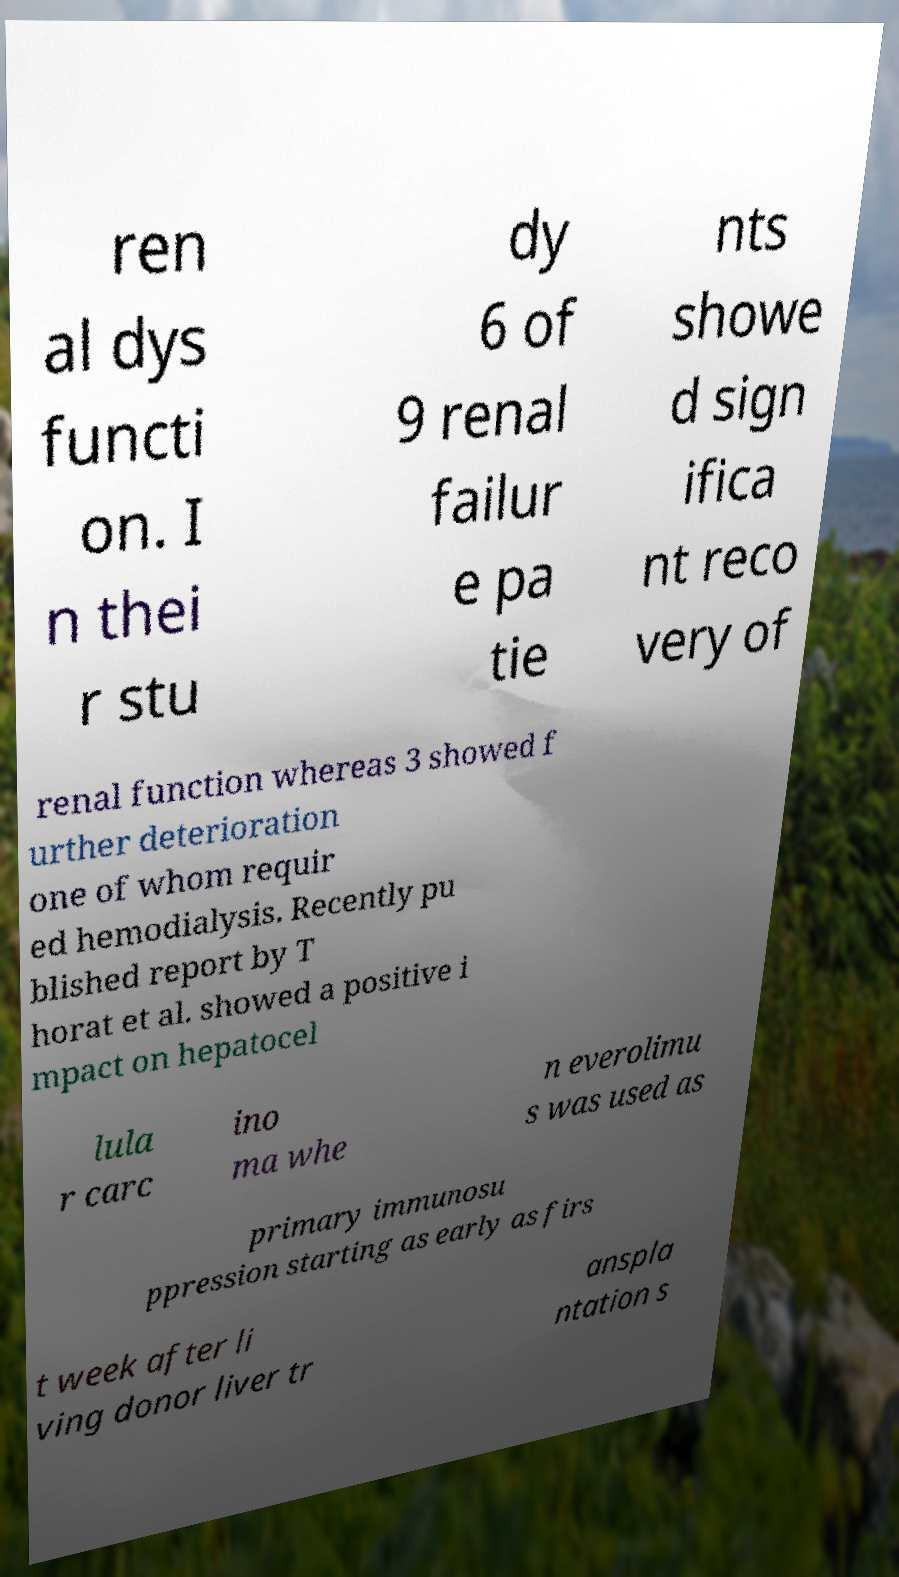Can you accurately transcribe the text from the provided image for me? ren al dys functi on. I n thei r stu dy 6 of 9 renal failur e pa tie nts showe d sign ifica nt reco very of renal function whereas 3 showed f urther deterioration one of whom requir ed hemodialysis. Recently pu blished report by T horat et al. showed a positive i mpact on hepatocel lula r carc ino ma whe n everolimu s was used as primary immunosu ppression starting as early as firs t week after li ving donor liver tr anspla ntation s 